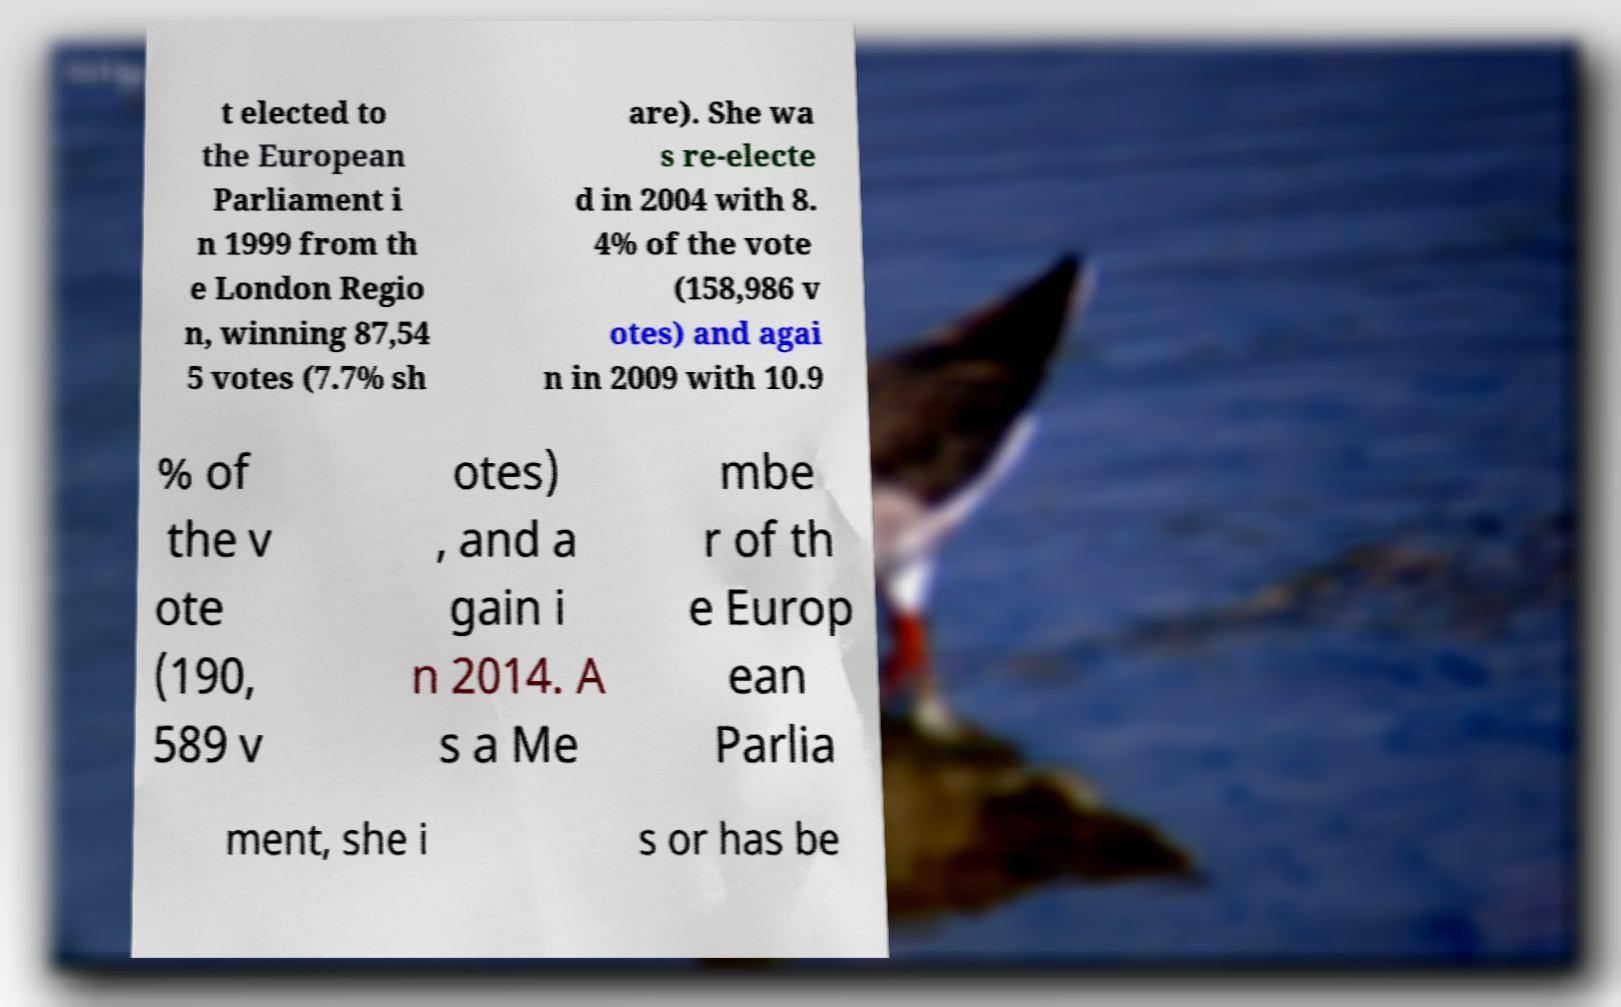I need the written content from this picture converted into text. Can you do that? t elected to the European Parliament i n 1999 from th e London Regio n, winning 87,54 5 votes (7.7% sh are). She wa s re-electe d in 2004 with 8. 4% of the vote (158,986 v otes) and agai n in 2009 with 10.9 % of the v ote (190, 589 v otes) , and a gain i n 2014. A s a Me mbe r of th e Europ ean Parlia ment, she i s or has be 